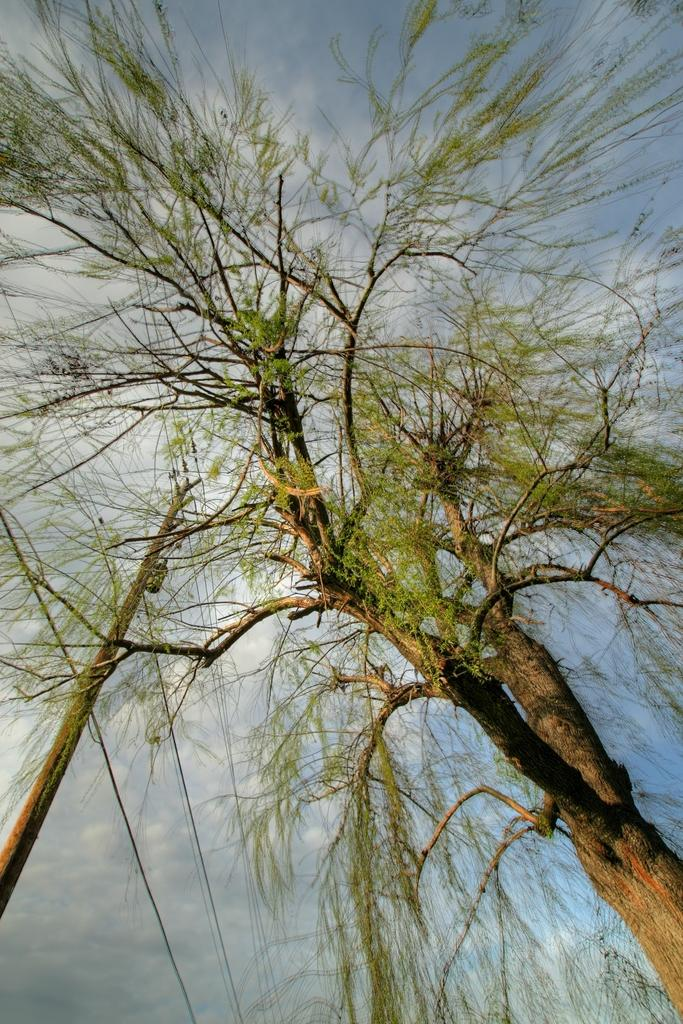What type of plant can be seen in the image? There is a tree in the image. What other object is present in the image? There is a pole in the image. What can be seen in the distance in the image? The sky is visible in the background of the image. What type of cork can be seen on the tree in the image? There is no cork present on the tree in the image. 